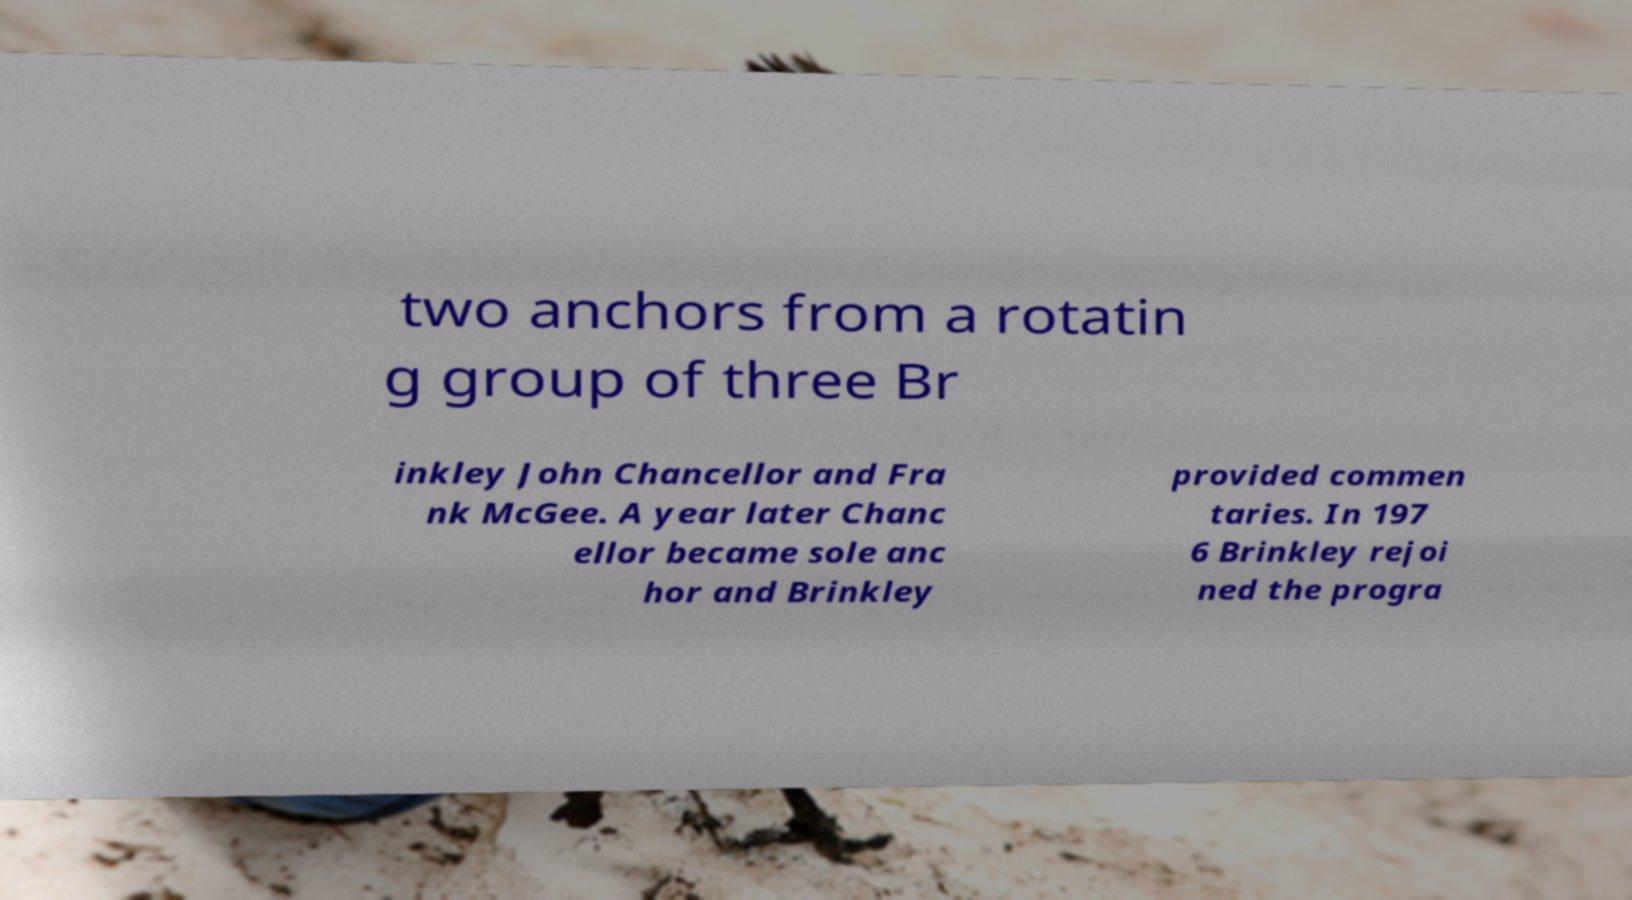Can you accurately transcribe the text from the provided image for me? two anchors from a rotatin g group of three Br inkley John Chancellor and Fra nk McGee. A year later Chanc ellor became sole anc hor and Brinkley provided commen taries. In 197 6 Brinkley rejoi ned the progra 